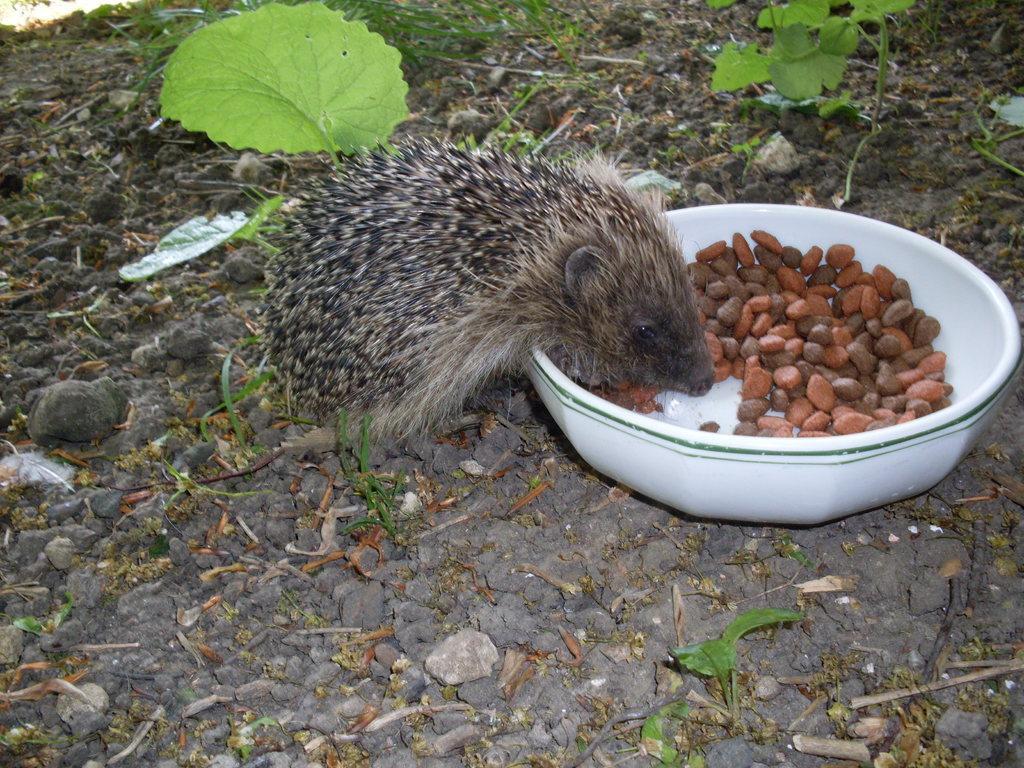How would you summarize this image in a sentence or two? In this image we can see porcupine and food in bowl placed on the ground. In the background we an see plants and ground. 